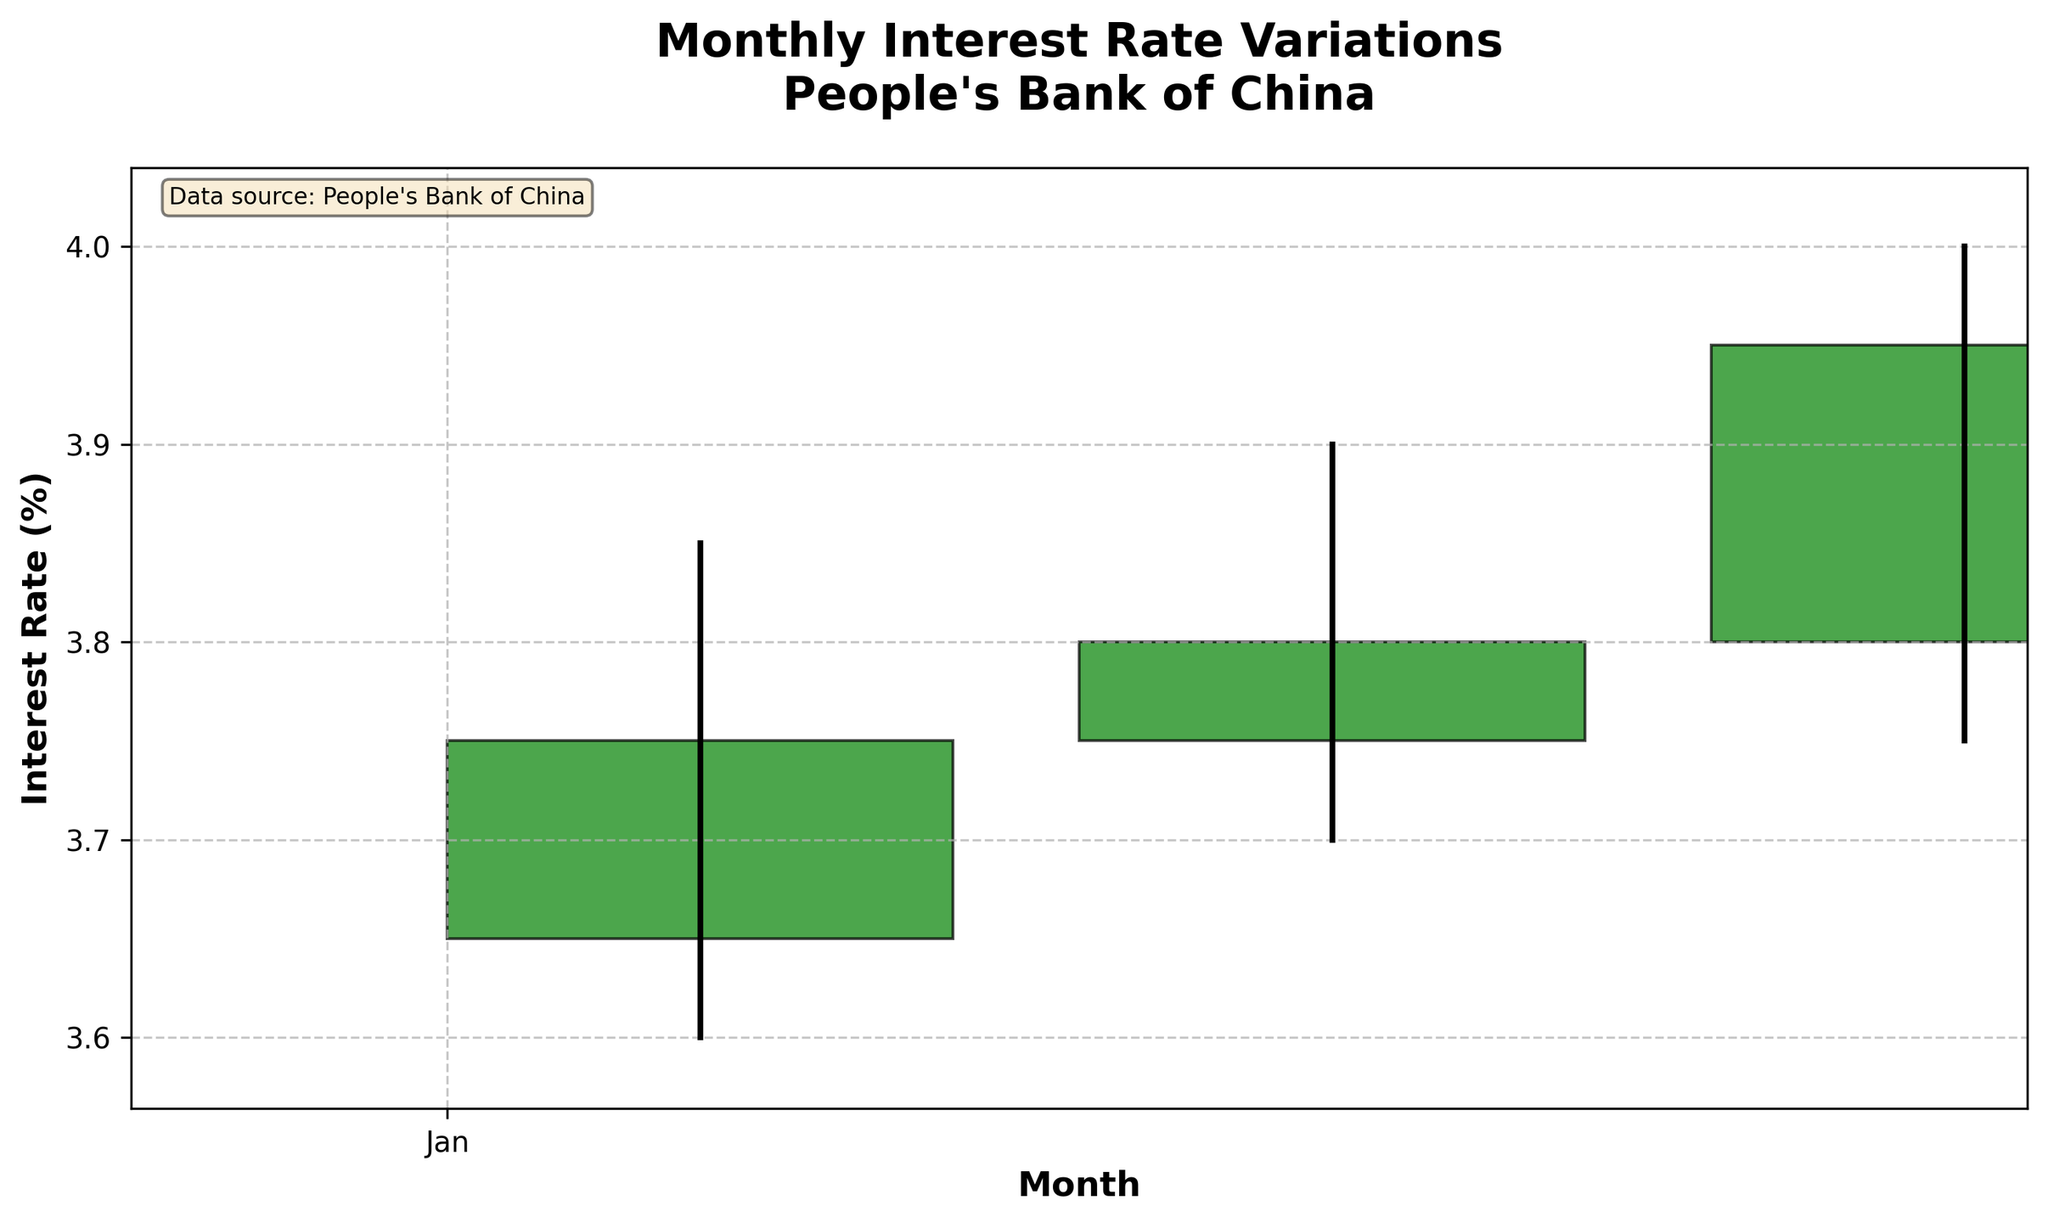What's the title of the figure? The title of the figure is located at the top and it is often the most prominent text.
Answer: "Monthly Interest Rate Variations People's Bank of China" What is the interest rate for January? Identify the value at the end of January's range indicated by the 'Close' value on the figure. The close value for January is 3.75%.
Answer: 3.75% Which month shows the highest interest rate? Find the month with the highest point on the y-axis among all months from the high values in the chart. March has a high of 4.00%.
Answer: March In which month did the interest rate increase the most compared to the previous month? Calculate the change in close values between consecutive months: Feb (3.80%) - Jan (3.75%) = 0.05%, and Mar (3.95%) - Feb (3.80%) = 0.15%. The greatest increase is between February and March, which is 0.15%.
Answer: March What is the lowest interest rate recorded over the quarter? Identify the minimum value indicated by the 'Low' values for January, February, and March. The lowest low value is 3.60% in January.
Answer: 3.60% What color is used to indicate a month where interest rates increased? The figure uses green to indicate an increase in interest rate, which is determined by comparing the 'Open' and 'Close' values; if 'Close' is higher than 'Open', the color is green.
Answer: Green Compare the range of interest rates in February to January. Which month had a larger range? Calculate the ranges: January's range is 3.85% - 3.60% = 0.25%, and February's range is 3.90% - 3.70% = 0.20%. January has a larger range.
Answer: January Did the interest rate ever close below the opening rate in any month? Check the difference between 'Close' and 'Open' for each month. All months have 'Close' equal to or greater than 'Open', hence there is no month with a Close below the Open.
Answer: No What are the months displayed on the x-axis? The x-axis displays the months January, February, and March as seen from the labels.
Answer: January, February, March 